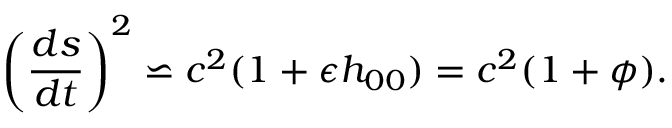<formula> <loc_0><loc_0><loc_500><loc_500>\left ( \frac { d s } { d t } \right ) ^ { 2 } \backsimeq c ^ { 2 } ( 1 + \epsilon h _ { 0 0 } ) = c ^ { 2 } ( 1 + \phi ) .</formula> 